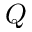<formula> <loc_0><loc_0><loc_500><loc_500>Q</formula> 